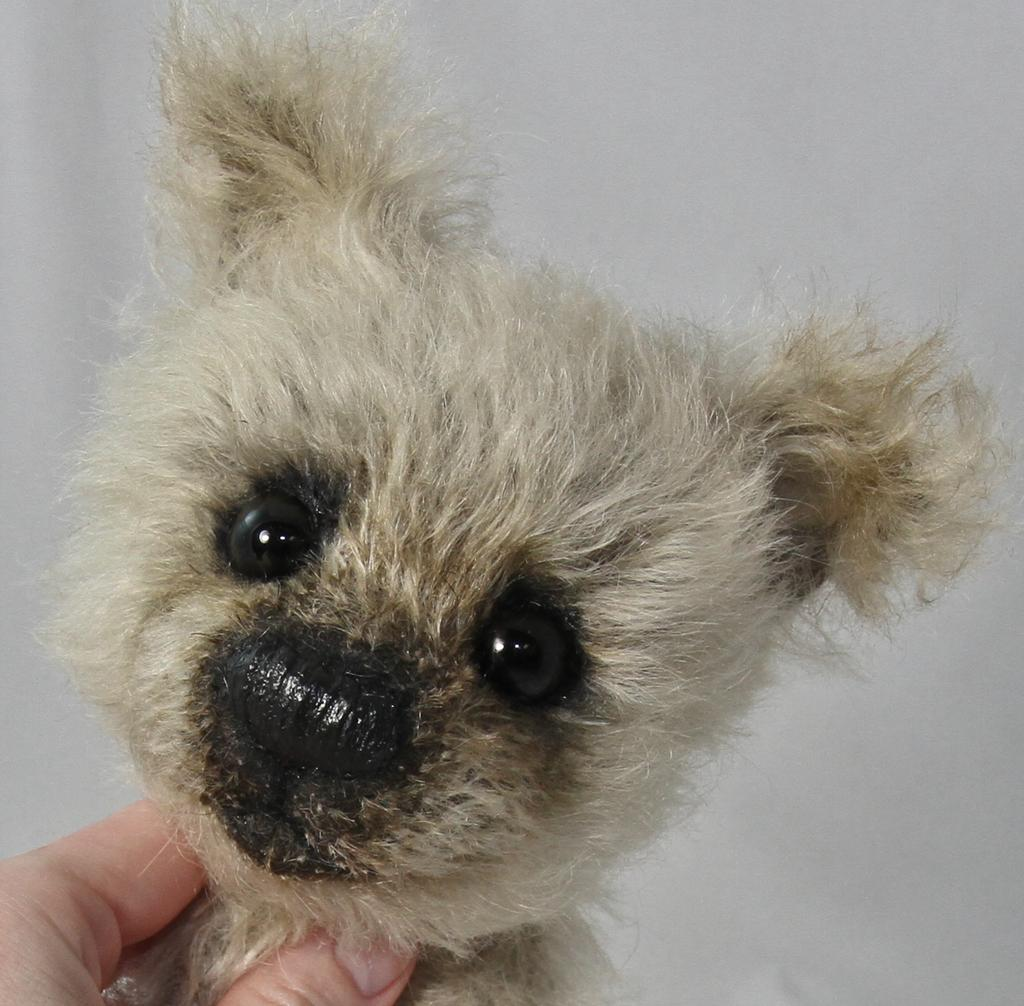What is the person holding in the image? The person is holding a toy in the image. What color is the background of the image? The background of the image is white. Is the library open during the rain in the image? There is no reference to a library or rain in the image, so it's not possible to answer that question. 